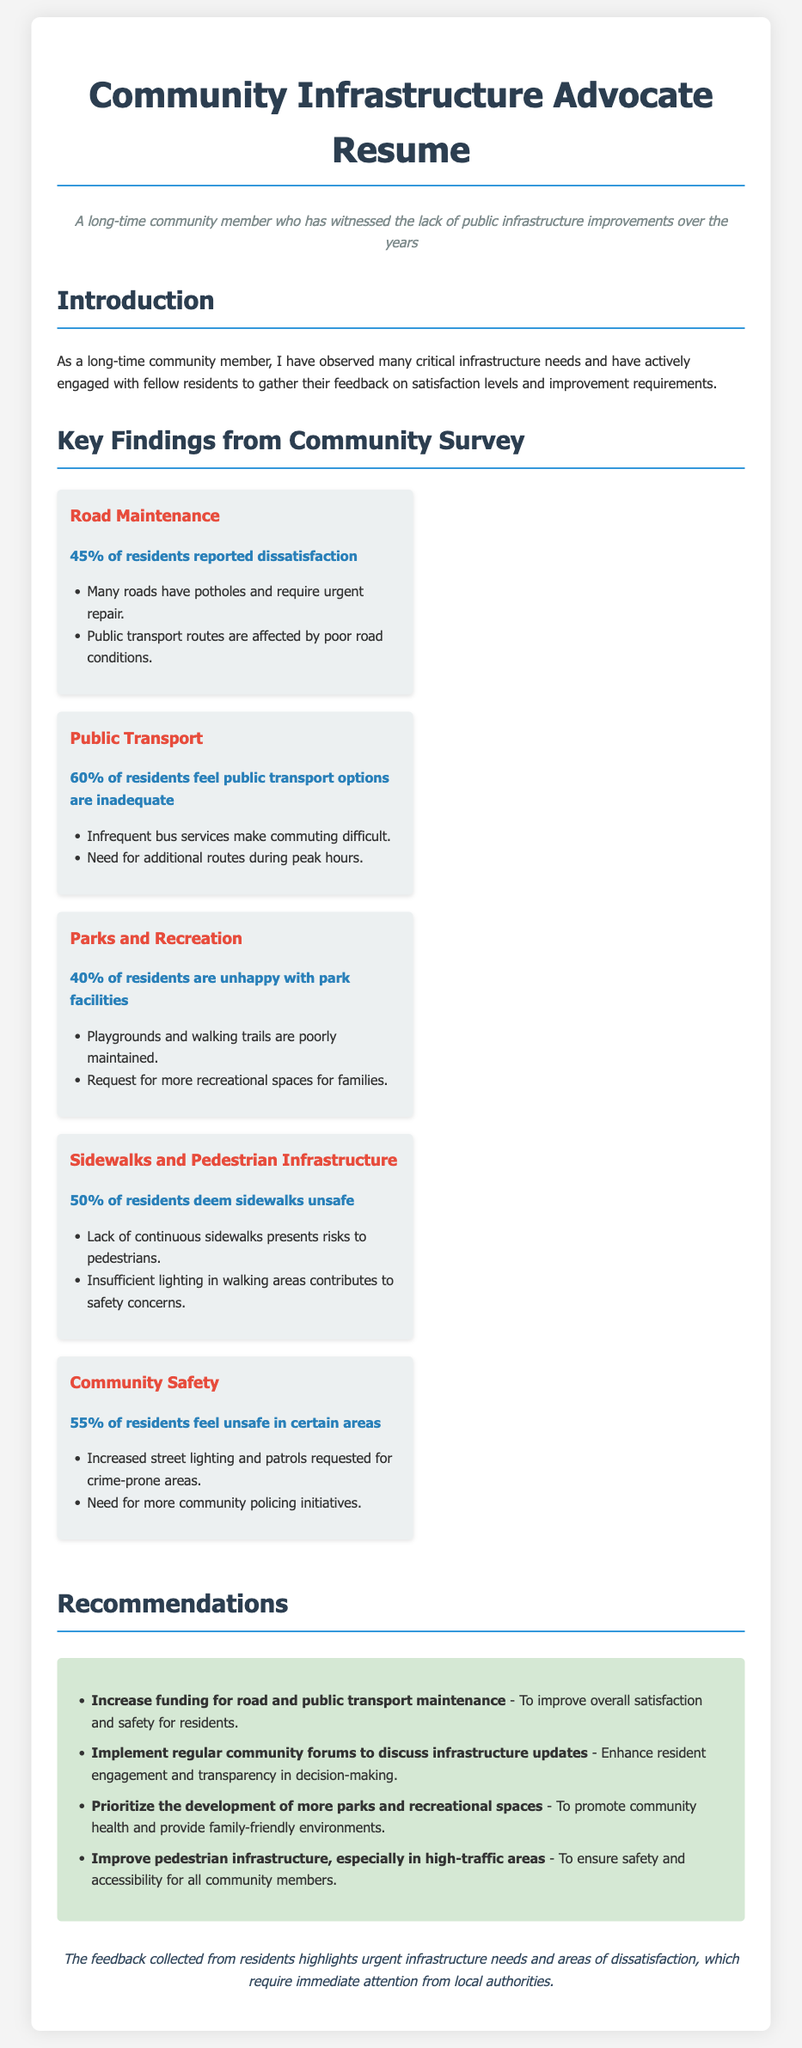What percentage of residents reported dissatisfaction with road maintenance? The document states that 45% of residents reported dissatisfaction regarding road maintenance.
Answer: 45% What is the main concern regarding public transport as per resident feedback? Residents feel public transport options are inadequate, with 60% expressing this sentiment.
Answer: Inadequate options How many residents feel unsafe in certain areas according to the survey? The document indicates that 55% of residents feel unsafe in certain areas.
Answer: 55% What recommendation is made to address pedestrian safety? The document recommends improving pedestrian infrastructure, especially in high-traffic areas.
Answer: Improve pedestrian infrastructure What percentage of residents is unhappy with park facilities? The document shows that 40% of residents are unhappy with park facilities.
Answer: 40% How many recommendations are listed in the document? The document outlines four recommendations for infrastructure improvement.
Answer: Four What aspect of sidewalks do 50% of residents deem unsafe? The document mentions that residents consider the lack of continuous sidewalks as a safety issue.
Answer: Lack of continuous sidewalks What is one of the community safety concerns mentioned? Residents requested increased street lighting and patrols for crime-prone areas.
Answer: Increased street lighting What is the title of the resume? The title of the resume is "Community Infrastructure Advocate Resume."
Answer: Community Infrastructure Advocate Resume 